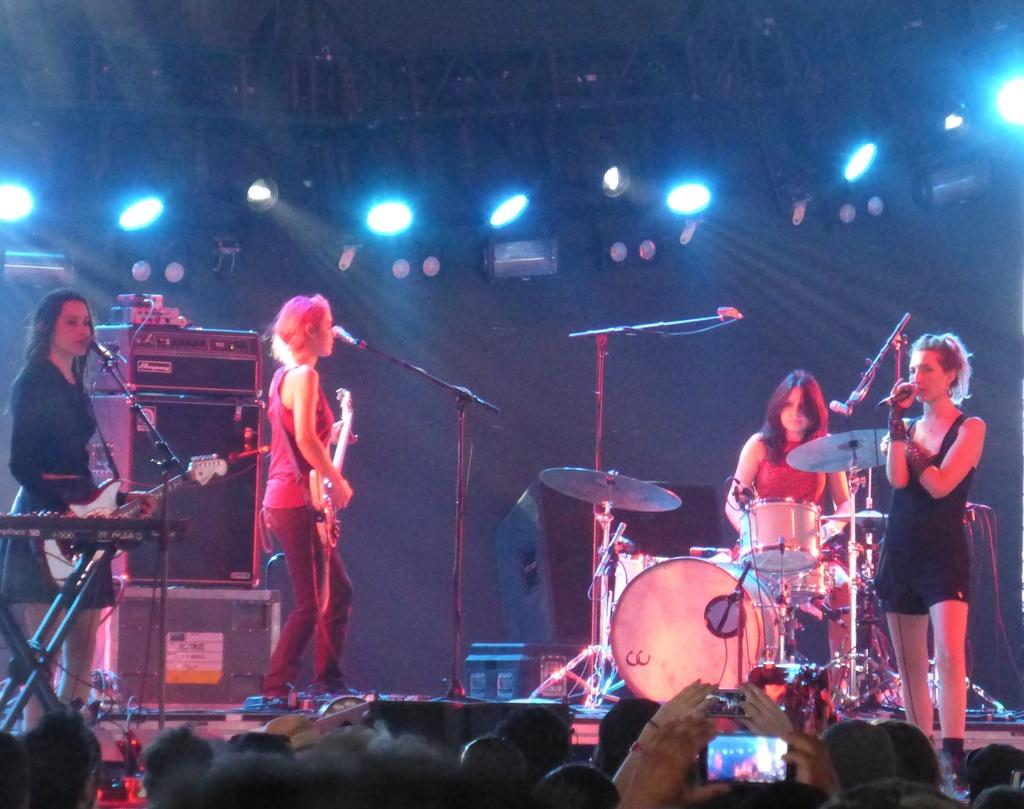How many people are in the image? There are people in the image, but the exact number is not specified. What are the people doing in the image? The people are standing and playing musical instruments. Can you describe the actions of the people in the image? The people are standing and using their hands to play musical instruments. How many chickens are visible in the image? There are no chickens present in the image. What type of star can be seen in the image? There is no star visible in the image. 